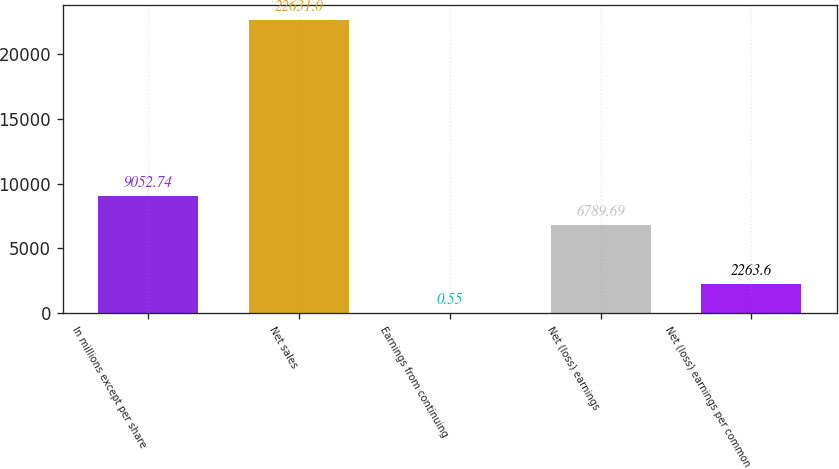Convert chart to OTSL. <chart><loc_0><loc_0><loc_500><loc_500><bar_chart><fcel>In millions except per share<fcel>Net sales<fcel>Earnings from continuing<fcel>Net (loss) earnings<fcel>Net (loss) earnings per common<nl><fcel>9052.74<fcel>22631<fcel>0.55<fcel>6789.69<fcel>2263.6<nl></chart> 